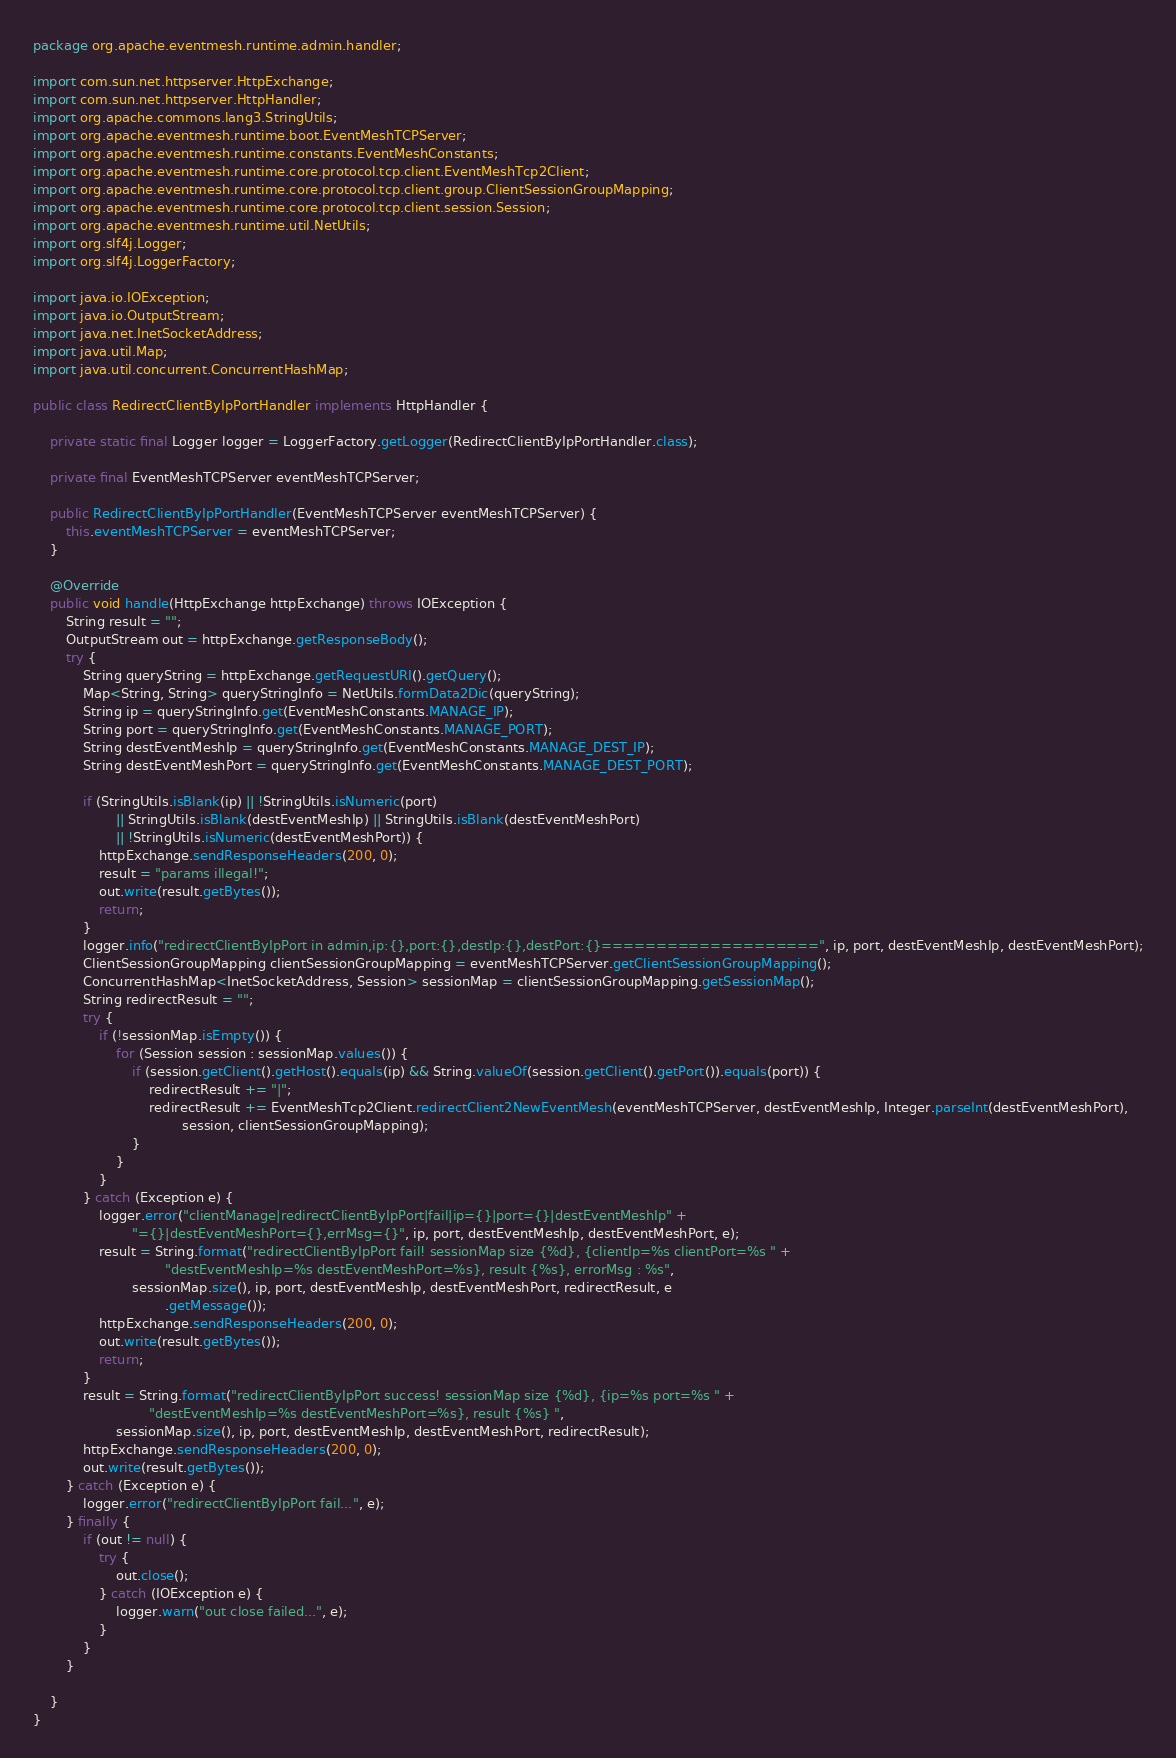Convert code to text. <code><loc_0><loc_0><loc_500><loc_500><_Java_>package org.apache.eventmesh.runtime.admin.handler;

import com.sun.net.httpserver.HttpExchange;
import com.sun.net.httpserver.HttpHandler;
import org.apache.commons.lang3.StringUtils;
import org.apache.eventmesh.runtime.boot.EventMeshTCPServer;
import org.apache.eventmesh.runtime.constants.EventMeshConstants;
import org.apache.eventmesh.runtime.core.protocol.tcp.client.EventMeshTcp2Client;
import org.apache.eventmesh.runtime.core.protocol.tcp.client.group.ClientSessionGroupMapping;
import org.apache.eventmesh.runtime.core.protocol.tcp.client.session.Session;
import org.apache.eventmesh.runtime.util.NetUtils;
import org.slf4j.Logger;
import org.slf4j.LoggerFactory;

import java.io.IOException;
import java.io.OutputStream;
import java.net.InetSocketAddress;
import java.util.Map;
import java.util.concurrent.ConcurrentHashMap;

public class RedirectClientByIpPortHandler implements HttpHandler {

    private static final Logger logger = LoggerFactory.getLogger(RedirectClientByIpPortHandler.class);

    private final EventMeshTCPServer eventMeshTCPServer;

    public RedirectClientByIpPortHandler(EventMeshTCPServer eventMeshTCPServer) {
        this.eventMeshTCPServer = eventMeshTCPServer;
    }

    @Override
    public void handle(HttpExchange httpExchange) throws IOException {
        String result = "";
        OutputStream out = httpExchange.getResponseBody();
        try {
            String queryString = httpExchange.getRequestURI().getQuery();
            Map<String, String> queryStringInfo = NetUtils.formData2Dic(queryString);
            String ip = queryStringInfo.get(EventMeshConstants.MANAGE_IP);
            String port = queryStringInfo.get(EventMeshConstants.MANAGE_PORT);
            String destEventMeshIp = queryStringInfo.get(EventMeshConstants.MANAGE_DEST_IP);
            String destEventMeshPort = queryStringInfo.get(EventMeshConstants.MANAGE_DEST_PORT);

            if (StringUtils.isBlank(ip) || !StringUtils.isNumeric(port)
                    || StringUtils.isBlank(destEventMeshIp) || StringUtils.isBlank(destEventMeshPort)
                    || !StringUtils.isNumeric(destEventMeshPort)) {
                httpExchange.sendResponseHeaders(200, 0);
                result = "params illegal!";
                out.write(result.getBytes());
                return;
            }
            logger.info("redirectClientByIpPort in admin,ip:{},port:{},destIp:{},destPort:{}====================", ip, port, destEventMeshIp, destEventMeshPort);
            ClientSessionGroupMapping clientSessionGroupMapping = eventMeshTCPServer.getClientSessionGroupMapping();
            ConcurrentHashMap<InetSocketAddress, Session> sessionMap = clientSessionGroupMapping.getSessionMap();
            String redirectResult = "";
            try {
                if (!sessionMap.isEmpty()) {
                    for (Session session : sessionMap.values()) {
                        if (session.getClient().getHost().equals(ip) && String.valueOf(session.getClient().getPort()).equals(port)) {
                            redirectResult += "|";
                            redirectResult += EventMeshTcp2Client.redirectClient2NewEventMesh(eventMeshTCPServer, destEventMeshIp, Integer.parseInt(destEventMeshPort),
                                    session, clientSessionGroupMapping);
                        }
                    }
                }
            } catch (Exception e) {
                logger.error("clientManage|redirectClientByIpPort|fail|ip={}|port={}|destEventMeshIp" +
                        "={}|destEventMeshPort={},errMsg={}", ip, port, destEventMeshIp, destEventMeshPort, e);
                result = String.format("redirectClientByIpPort fail! sessionMap size {%d}, {clientIp=%s clientPort=%s " +
                                "destEventMeshIp=%s destEventMeshPort=%s}, result {%s}, errorMsg : %s",
                        sessionMap.size(), ip, port, destEventMeshIp, destEventMeshPort, redirectResult, e
                                .getMessage());
                httpExchange.sendResponseHeaders(200, 0);
                out.write(result.getBytes());
                return;
            }
            result = String.format("redirectClientByIpPort success! sessionMap size {%d}, {ip=%s port=%s " +
                            "destEventMeshIp=%s destEventMeshPort=%s}, result {%s} ",
                    sessionMap.size(), ip, port, destEventMeshIp, destEventMeshPort, redirectResult);
            httpExchange.sendResponseHeaders(200, 0);
            out.write(result.getBytes());
        } catch (Exception e) {
            logger.error("redirectClientByIpPort fail...", e);
        } finally {
            if (out != null) {
                try {
                    out.close();
                } catch (IOException e) {
                    logger.warn("out close failed...", e);
                }
            }
        }

    }
}
</code> 